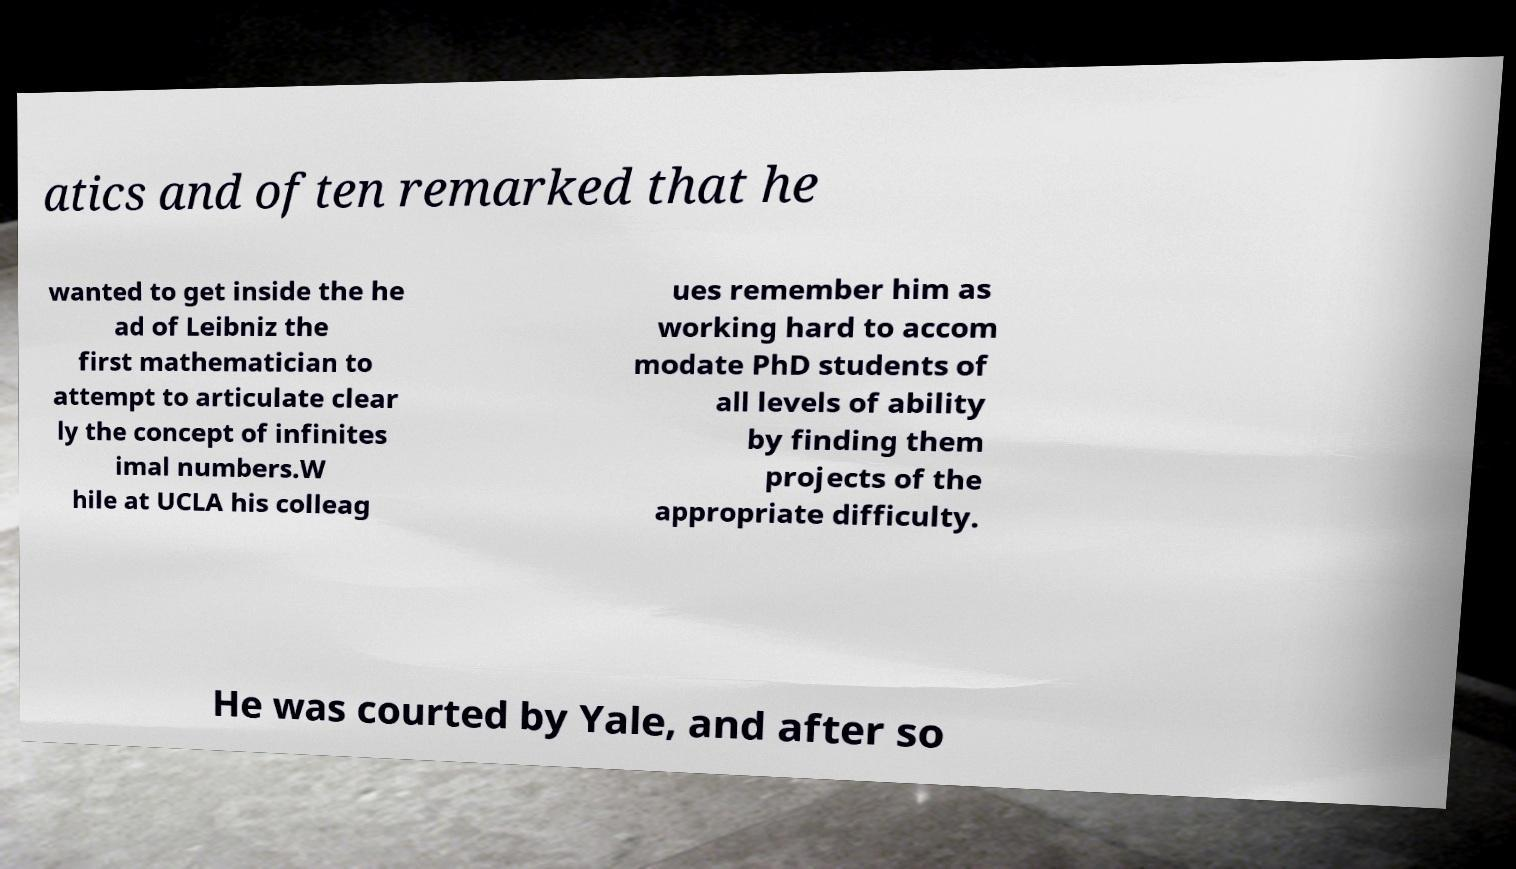Could you extract and type out the text from this image? atics and often remarked that he wanted to get inside the he ad of Leibniz the first mathematician to attempt to articulate clear ly the concept of infinites imal numbers.W hile at UCLA his colleag ues remember him as working hard to accom modate PhD students of all levels of ability by finding them projects of the appropriate difficulty. He was courted by Yale, and after so 